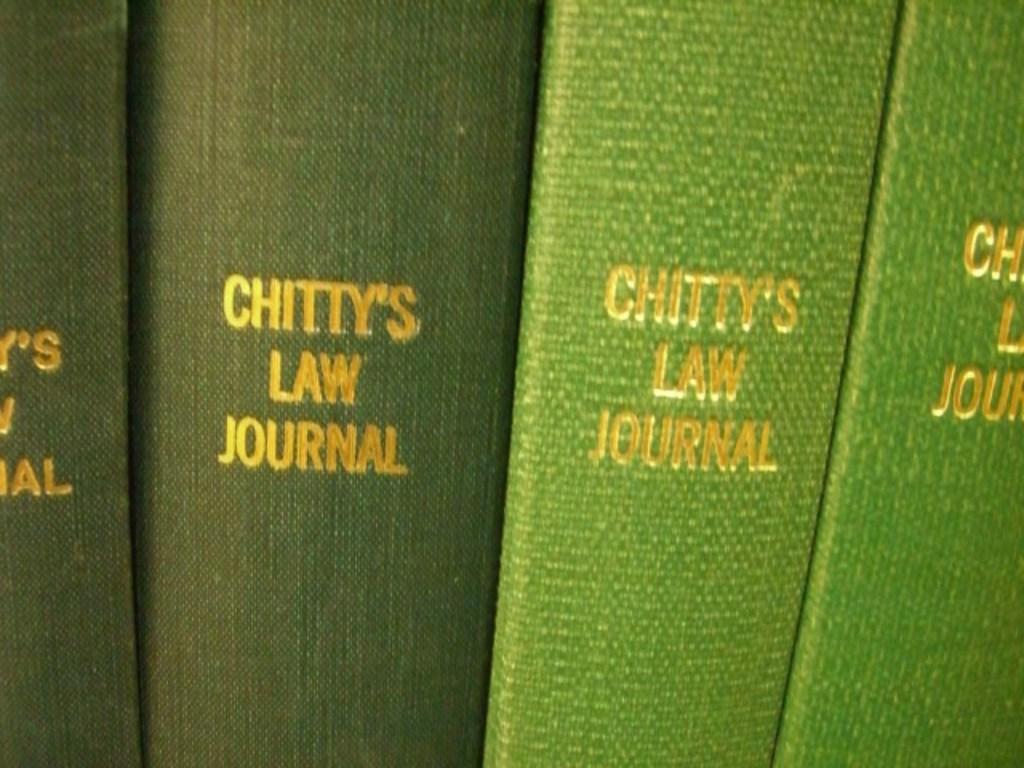Please provide a concise description of this image. Here we can see objects and there is text written on the each object. 